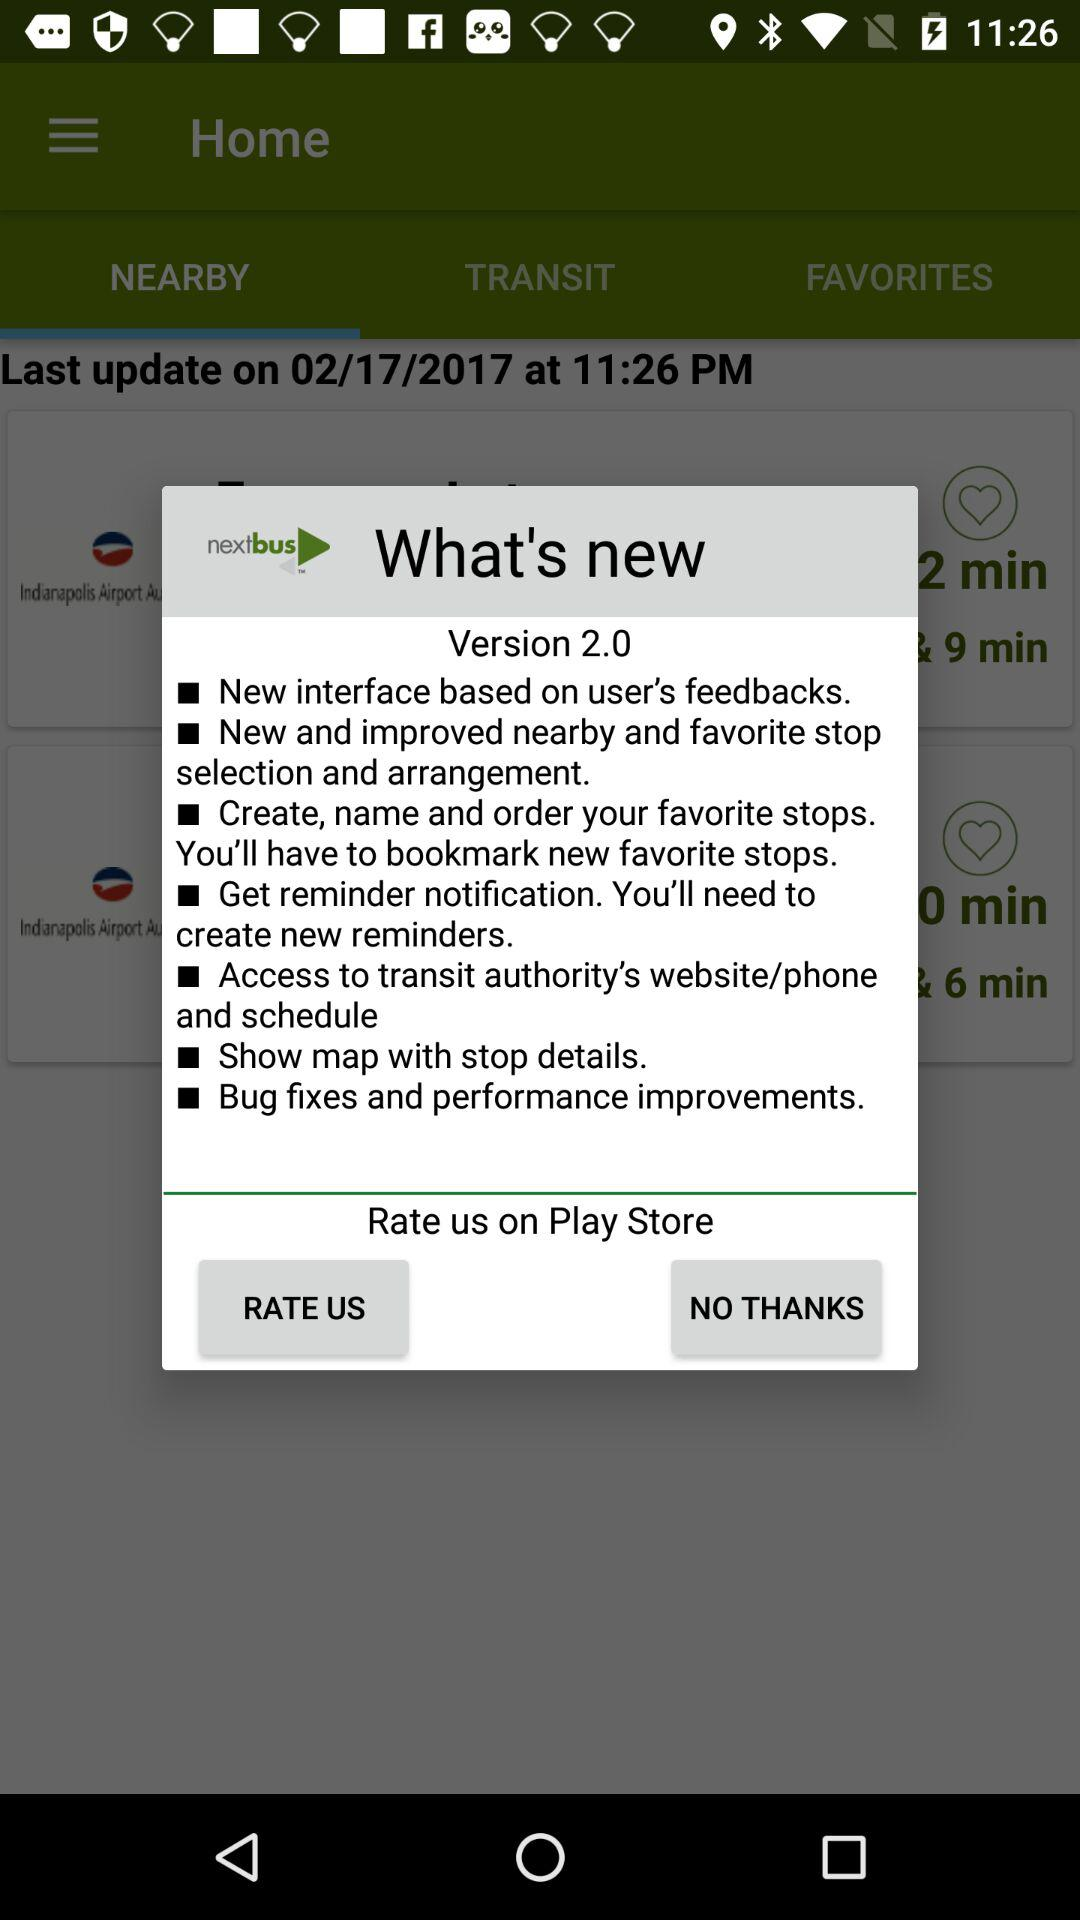Which app version are we using? You are using version 2.0. 